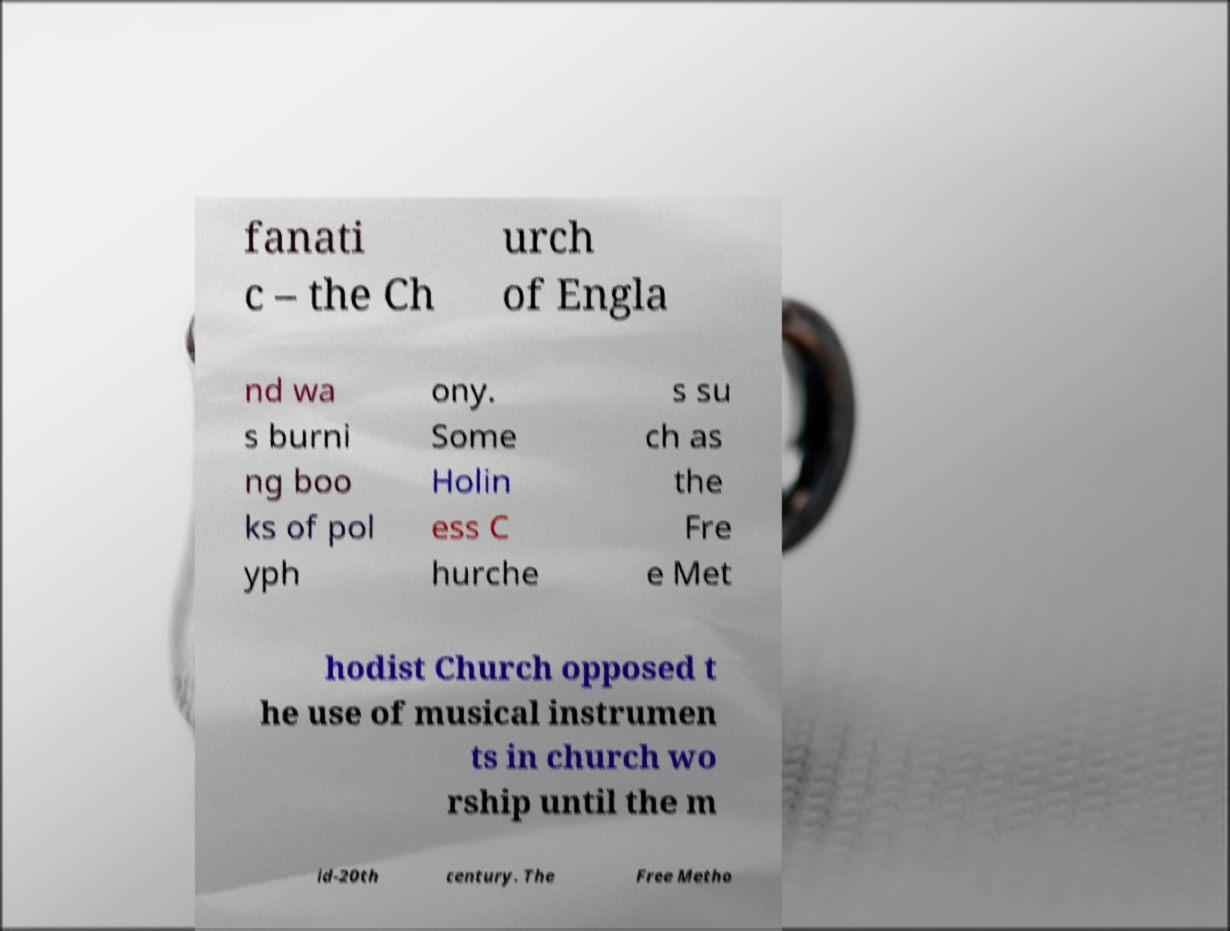There's text embedded in this image that I need extracted. Can you transcribe it verbatim? fanati c – the Ch urch of Engla nd wa s burni ng boo ks of pol yph ony. Some Holin ess C hurche s su ch as the Fre e Met hodist Church opposed t he use of musical instrumen ts in church wo rship until the m id-20th century. The Free Metho 